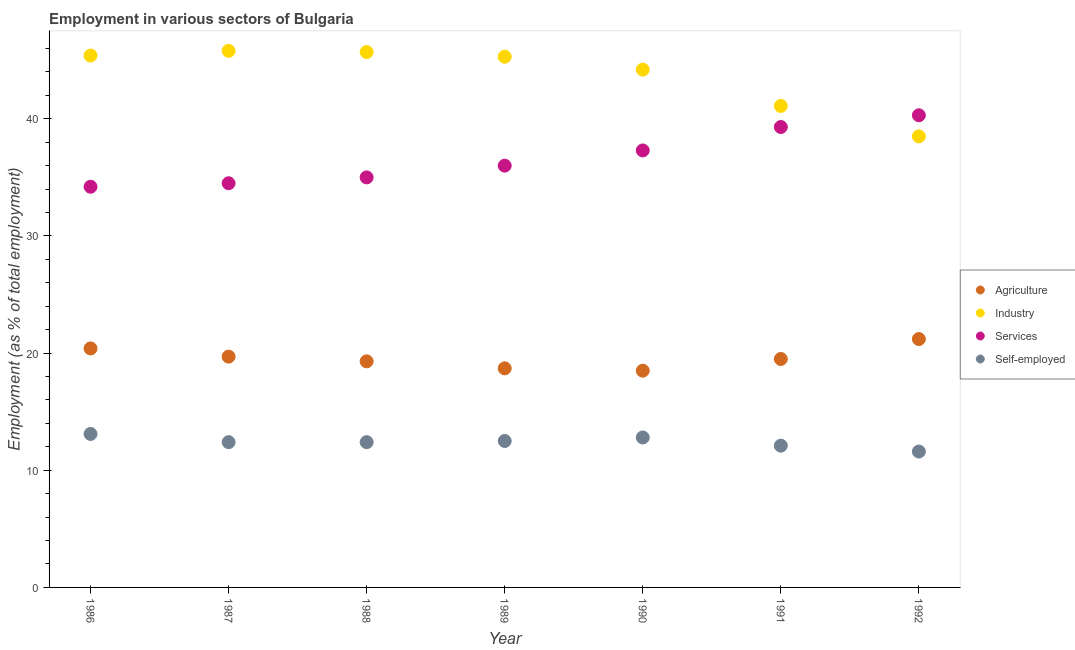How many different coloured dotlines are there?
Your response must be concise. 4. What is the percentage of workers in agriculture in 1988?
Provide a short and direct response. 19.3. Across all years, what is the maximum percentage of workers in services?
Your answer should be very brief. 40.3. Across all years, what is the minimum percentage of workers in industry?
Your answer should be compact. 38.5. In which year was the percentage of workers in industry maximum?
Offer a terse response. 1987. In which year was the percentage of self employed workers minimum?
Make the answer very short. 1992. What is the total percentage of workers in services in the graph?
Ensure brevity in your answer.  256.6. What is the difference between the percentage of workers in agriculture in 1989 and that in 1991?
Provide a short and direct response. -0.8. What is the difference between the percentage of workers in services in 1987 and the percentage of self employed workers in 1988?
Keep it short and to the point. 22.1. What is the average percentage of workers in services per year?
Keep it short and to the point. 36.66. In the year 1988, what is the difference between the percentage of workers in services and percentage of workers in agriculture?
Keep it short and to the point. 15.7. What is the ratio of the percentage of workers in agriculture in 1986 to that in 1988?
Your answer should be compact. 1.06. Is the percentage of workers in services in 1988 less than that in 1992?
Your answer should be very brief. Yes. Is the difference between the percentage of workers in services in 1990 and 1991 greater than the difference between the percentage of self employed workers in 1990 and 1991?
Keep it short and to the point. No. What is the difference between the highest and the second highest percentage of workers in industry?
Provide a succinct answer. 0.1. What is the difference between the highest and the lowest percentage of workers in services?
Ensure brevity in your answer.  6.1. Is it the case that in every year, the sum of the percentage of self employed workers and percentage of workers in services is greater than the sum of percentage of workers in industry and percentage of workers in agriculture?
Provide a succinct answer. Yes. Is it the case that in every year, the sum of the percentage of workers in agriculture and percentage of workers in industry is greater than the percentage of workers in services?
Provide a short and direct response. Yes. Is the percentage of workers in services strictly less than the percentage of workers in industry over the years?
Ensure brevity in your answer.  No. Are the values on the major ticks of Y-axis written in scientific E-notation?
Offer a very short reply. No. Does the graph contain grids?
Keep it short and to the point. No. How are the legend labels stacked?
Your answer should be compact. Vertical. What is the title of the graph?
Make the answer very short. Employment in various sectors of Bulgaria. Does "Salary of employees" appear as one of the legend labels in the graph?
Provide a short and direct response. No. What is the label or title of the Y-axis?
Ensure brevity in your answer.  Employment (as % of total employment). What is the Employment (as % of total employment) of Agriculture in 1986?
Make the answer very short. 20.4. What is the Employment (as % of total employment) in Industry in 1986?
Make the answer very short. 45.4. What is the Employment (as % of total employment) in Services in 1986?
Make the answer very short. 34.2. What is the Employment (as % of total employment) in Self-employed in 1986?
Give a very brief answer. 13.1. What is the Employment (as % of total employment) in Agriculture in 1987?
Ensure brevity in your answer.  19.7. What is the Employment (as % of total employment) of Industry in 1987?
Your response must be concise. 45.8. What is the Employment (as % of total employment) in Services in 1987?
Your answer should be very brief. 34.5. What is the Employment (as % of total employment) of Self-employed in 1987?
Your answer should be very brief. 12.4. What is the Employment (as % of total employment) in Agriculture in 1988?
Provide a succinct answer. 19.3. What is the Employment (as % of total employment) of Industry in 1988?
Your response must be concise. 45.7. What is the Employment (as % of total employment) of Self-employed in 1988?
Your answer should be compact. 12.4. What is the Employment (as % of total employment) of Agriculture in 1989?
Your answer should be very brief. 18.7. What is the Employment (as % of total employment) in Industry in 1989?
Your answer should be compact. 45.3. What is the Employment (as % of total employment) in Services in 1989?
Provide a succinct answer. 36. What is the Employment (as % of total employment) in Self-employed in 1989?
Ensure brevity in your answer.  12.5. What is the Employment (as % of total employment) of Industry in 1990?
Provide a succinct answer. 44.2. What is the Employment (as % of total employment) of Services in 1990?
Your response must be concise. 37.3. What is the Employment (as % of total employment) in Self-employed in 1990?
Give a very brief answer. 12.8. What is the Employment (as % of total employment) of Agriculture in 1991?
Keep it short and to the point. 19.5. What is the Employment (as % of total employment) in Industry in 1991?
Offer a terse response. 41.1. What is the Employment (as % of total employment) of Services in 1991?
Offer a terse response. 39.3. What is the Employment (as % of total employment) in Self-employed in 1991?
Keep it short and to the point. 12.1. What is the Employment (as % of total employment) in Agriculture in 1992?
Keep it short and to the point. 21.2. What is the Employment (as % of total employment) of Industry in 1992?
Your answer should be very brief. 38.5. What is the Employment (as % of total employment) in Services in 1992?
Your answer should be very brief. 40.3. What is the Employment (as % of total employment) of Self-employed in 1992?
Provide a succinct answer. 11.6. Across all years, what is the maximum Employment (as % of total employment) in Agriculture?
Offer a terse response. 21.2. Across all years, what is the maximum Employment (as % of total employment) of Industry?
Make the answer very short. 45.8. Across all years, what is the maximum Employment (as % of total employment) in Services?
Provide a short and direct response. 40.3. Across all years, what is the maximum Employment (as % of total employment) in Self-employed?
Offer a very short reply. 13.1. Across all years, what is the minimum Employment (as % of total employment) of Agriculture?
Offer a terse response. 18.5. Across all years, what is the minimum Employment (as % of total employment) in Industry?
Give a very brief answer. 38.5. Across all years, what is the minimum Employment (as % of total employment) of Services?
Your answer should be compact. 34.2. Across all years, what is the minimum Employment (as % of total employment) in Self-employed?
Provide a succinct answer. 11.6. What is the total Employment (as % of total employment) of Agriculture in the graph?
Ensure brevity in your answer.  137.3. What is the total Employment (as % of total employment) of Industry in the graph?
Provide a short and direct response. 306. What is the total Employment (as % of total employment) in Services in the graph?
Give a very brief answer. 256.6. What is the total Employment (as % of total employment) in Self-employed in the graph?
Give a very brief answer. 86.9. What is the difference between the Employment (as % of total employment) in Agriculture in 1986 and that in 1987?
Your answer should be compact. 0.7. What is the difference between the Employment (as % of total employment) of Services in 1986 and that in 1987?
Keep it short and to the point. -0.3. What is the difference between the Employment (as % of total employment) of Industry in 1986 and that in 1988?
Make the answer very short. -0.3. What is the difference between the Employment (as % of total employment) in Self-employed in 1986 and that in 1988?
Make the answer very short. 0.7. What is the difference between the Employment (as % of total employment) in Agriculture in 1986 and that in 1989?
Ensure brevity in your answer.  1.7. What is the difference between the Employment (as % of total employment) of Services in 1986 and that in 1989?
Keep it short and to the point. -1.8. What is the difference between the Employment (as % of total employment) in Self-employed in 1986 and that in 1989?
Provide a short and direct response. 0.6. What is the difference between the Employment (as % of total employment) of Industry in 1986 and that in 1991?
Your answer should be very brief. 4.3. What is the difference between the Employment (as % of total employment) of Services in 1986 and that in 1991?
Your response must be concise. -5.1. What is the difference between the Employment (as % of total employment) of Industry in 1986 and that in 1992?
Provide a succinct answer. 6.9. What is the difference between the Employment (as % of total employment) of Agriculture in 1987 and that in 1988?
Offer a terse response. 0.4. What is the difference between the Employment (as % of total employment) of Industry in 1987 and that in 1988?
Ensure brevity in your answer.  0.1. What is the difference between the Employment (as % of total employment) in Services in 1987 and that in 1988?
Provide a short and direct response. -0.5. What is the difference between the Employment (as % of total employment) in Agriculture in 1987 and that in 1989?
Your answer should be very brief. 1. What is the difference between the Employment (as % of total employment) of Self-employed in 1987 and that in 1989?
Provide a short and direct response. -0.1. What is the difference between the Employment (as % of total employment) of Industry in 1987 and that in 1990?
Make the answer very short. 1.6. What is the difference between the Employment (as % of total employment) in Services in 1987 and that in 1990?
Make the answer very short. -2.8. What is the difference between the Employment (as % of total employment) of Self-employed in 1987 and that in 1990?
Offer a very short reply. -0.4. What is the difference between the Employment (as % of total employment) in Services in 1987 and that in 1991?
Your answer should be very brief. -4.8. What is the difference between the Employment (as % of total employment) in Self-employed in 1987 and that in 1991?
Your answer should be very brief. 0.3. What is the difference between the Employment (as % of total employment) of Industry in 1987 and that in 1992?
Keep it short and to the point. 7.3. What is the difference between the Employment (as % of total employment) of Services in 1987 and that in 1992?
Provide a short and direct response. -5.8. What is the difference between the Employment (as % of total employment) in Agriculture in 1988 and that in 1989?
Offer a very short reply. 0.6. What is the difference between the Employment (as % of total employment) in Services in 1988 and that in 1989?
Ensure brevity in your answer.  -1. What is the difference between the Employment (as % of total employment) of Self-employed in 1988 and that in 1989?
Provide a short and direct response. -0.1. What is the difference between the Employment (as % of total employment) of Agriculture in 1988 and that in 1990?
Offer a terse response. 0.8. What is the difference between the Employment (as % of total employment) of Industry in 1988 and that in 1990?
Your answer should be compact. 1.5. What is the difference between the Employment (as % of total employment) in Industry in 1988 and that in 1991?
Provide a succinct answer. 4.6. What is the difference between the Employment (as % of total employment) in Services in 1988 and that in 1991?
Keep it short and to the point. -4.3. What is the difference between the Employment (as % of total employment) of Agriculture in 1989 and that in 1990?
Provide a succinct answer. 0.2. What is the difference between the Employment (as % of total employment) in Self-employed in 1989 and that in 1990?
Keep it short and to the point. -0.3. What is the difference between the Employment (as % of total employment) in Agriculture in 1989 and that in 1991?
Give a very brief answer. -0.8. What is the difference between the Employment (as % of total employment) in Industry in 1989 and that in 1991?
Provide a short and direct response. 4.2. What is the difference between the Employment (as % of total employment) of Agriculture in 1989 and that in 1992?
Ensure brevity in your answer.  -2.5. What is the difference between the Employment (as % of total employment) in Industry in 1989 and that in 1992?
Provide a short and direct response. 6.8. What is the difference between the Employment (as % of total employment) in Industry in 1990 and that in 1991?
Provide a succinct answer. 3.1. What is the difference between the Employment (as % of total employment) in Self-employed in 1990 and that in 1991?
Your answer should be very brief. 0.7. What is the difference between the Employment (as % of total employment) in Agriculture in 1990 and that in 1992?
Provide a succinct answer. -2.7. What is the difference between the Employment (as % of total employment) in Services in 1990 and that in 1992?
Your response must be concise. -3. What is the difference between the Employment (as % of total employment) of Self-employed in 1990 and that in 1992?
Make the answer very short. 1.2. What is the difference between the Employment (as % of total employment) in Agriculture in 1991 and that in 1992?
Provide a succinct answer. -1.7. What is the difference between the Employment (as % of total employment) of Industry in 1991 and that in 1992?
Offer a very short reply. 2.6. What is the difference between the Employment (as % of total employment) of Services in 1991 and that in 1992?
Keep it short and to the point. -1. What is the difference between the Employment (as % of total employment) of Self-employed in 1991 and that in 1992?
Give a very brief answer. 0.5. What is the difference between the Employment (as % of total employment) of Agriculture in 1986 and the Employment (as % of total employment) of Industry in 1987?
Ensure brevity in your answer.  -25.4. What is the difference between the Employment (as % of total employment) of Agriculture in 1986 and the Employment (as % of total employment) of Services in 1987?
Offer a very short reply. -14.1. What is the difference between the Employment (as % of total employment) in Industry in 1986 and the Employment (as % of total employment) in Services in 1987?
Provide a succinct answer. 10.9. What is the difference between the Employment (as % of total employment) of Services in 1986 and the Employment (as % of total employment) of Self-employed in 1987?
Provide a succinct answer. 21.8. What is the difference between the Employment (as % of total employment) of Agriculture in 1986 and the Employment (as % of total employment) of Industry in 1988?
Give a very brief answer. -25.3. What is the difference between the Employment (as % of total employment) in Agriculture in 1986 and the Employment (as % of total employment) in Services in 1988?
Keep it short and to the point. -14.6. What is the difference between the Employment (as % of total employment) in Agriculture in 1986 and the Employment (as % of total employment) in Self-employed in 1988?
Your answer should be compact. 8. What is the difference between the Employment (as % of total employment) in Industry in 1986 and the Employment (as % of total employment) in Services in 1988?
Ensure brevity in your answer.  10.4. What is the difference between the Employment (as % of total employment) of Services in 1986 and the Employment (as % of total employment) of Self-employed in 1988?
Offer a very short reply. 21.8. What is the difference between the Employment (as % of total employment) of Agriculture in 1986 and the Employment (as % of total employment) of Industry in 1989?
Your response must be concise. -24.9. What is the difference between the Employment (as % of total employment) of Agriculture in 1986 and the Employment (as % of total employment) of Services in 1989?
Ensure brevity in your answer.  -15.6. What is the difference between the Employment (as % of total employment) in Agriculture in 1986 and the Employment (as % of total employment) in Self-employed in 1989?
Your response must be concise. 7.9. What is the difference between the Employment (as % of total employment) in Industry in 1986 and the Employment (as % of total employment) in Self-employed in 1989?
Provide a short and direct response. 32.9. What is the difference between the Employment (as % of total employment) in Services in 1986 and the Employment (as % of total employment) in Self-employed in 1989?
Offer a terse response. 21.7. What is the difference between the Employment (as % of total employment) in Agriculture in 1986 and the Employment (as % of total employment) in Industry in 1990?
Your response must be concise. -23.8. What is the difference between the Employment (as % of total employment) of Agriculture in 1986 and the Employment (as % of total employment) of Services in 1990?
Ensure brevity in your answer.  -16.9. What is the difference between the Employment (as % of total employment) in Agriculture in 1986 and the Employment (as % of total employment) in Self-employed in 1990?
Provide a succinct answer. 7.6. What is the difference between the Employment (as % of total employment) of Industry in 1986 and the Employment (as % of total employment) of Services in 1990?
Your answer should be very brief. 8.1. What is the difference between the Employment (as % of total employment) in Industry in 1986 and the Employment (as % of total employment) in Self-employed in 1990?
Give a very brief answer. 32.6. What is the difference between the Employment (as % of total employment) of Services in 1986 and the Employment (as % of total employment) of Self-employed in 1990?
Your answer should be compact. 21.4. What is the difference between the Employment (as % of total employment) of Agriculture in 1986 and the Employment (as % of total employment) of Industry in 1991?
Your answer should be very brief. -20.7. What is the difference between the Employment (as % of total employment) of Agriculture in 1986 and the Employment (as % of total employment) of Services in 1991?
Ensure brevity in your answer.  -18.9. What is the difference between the Employment (as % of total employment) in Agriculture in 1986 and the Employment (as % of total employment) in Self-employed in 1991?
Offer a very short reply. 8.3. What is the difference between the Employment (as % of total employment) of Industry in 1986 and the Employment (as % of total employment) of Self-employed in 1991?
Make the answer very short. 33.3. What is the difference between the Employment (as % of total employment) of Services in 1986 and the Employment (as % of total employment) of Self-employed in 1991?
Make the answer very short. 22.1. What is the difference between the Employment (as % of total employment) of Agriculture in 1986 and the Employment (as % of total employment) of Industry in 1992?
Ensure brevity in your answer.  -18.1. What is the difference between the Employment (as % of total employment) of Agriculture in 1986 and the Employment (as % of total employment) of Services in 1992?
Offer a terse response. -19.9. What is the difference between the Employment (as % of total employment) of Industry in 1986 and the Employment (as % of total employment) of Self-employed in 1992?
Provide a short and direct response. 33.8. What is the difference between the Employment (as % of total employment) of Services in 1986 and the Employment (as % of total employment) of Self-employed in 1992?
Your response must be concise. 22.6. What is the difference between the Employment (as % of total employment) of Agriculture in 1987 and the Employment (as % of total employment) of Industry in 1988?
Offer a very short reply. -26. What is the difference between the Employment (as % of total employment) in Agriculture in 1987 and the Employment (as % of total employment) in Services in 1988?
Your answer should be compact. -15.3. What is the difference between the Employment (as % of total employment) in Agriculture in 1987 and the Employment (as % of total employment) in Self-employed in 1988?
Provide a succinct answer. 7.3. What is the difference between the Employment (as % of total employment) in Industry in 1987 and the Employment (as % of total employment) in Services in 1988?
Your answer should be very brief. 10.8. What is the difference between the Employment (as % of total employment) of Industry in 1987 and the Employment (as % of total employment) of Self-employed in 1988?
Your answer should be very brief. 33.4. What is the difference between the Employment (as % of total employment) in Services in 1987 and the Employment (as % of total employment) in Self-employed in 1988?
Give a very brief answer. 22.1. What is the difference between the Employment (as % of total employment) in Agriculture in 1987 and the Employment (as % of total employment) in Industry in 1989?
Provide a succinct answer. -25.6. What is the difference between the Employment (as % of total employment) in Agriculture in 1987 and the Employment (as % of total employment) in Services in 1989?
Your answer should be very brief. -16.3. What is the difference between the Employment (as % of total employment) of Industry in 1987 and the Employment (as % of total employment) of Self-employed in 1989?
Your response must be concise. 33.3. What is the difference between the Employment (as % of total employment) of Agriculture in 1987 and the Employment (as % of total employment) of Industry in 1990?
Offer a very short reply. -24.5. What is the difference between the Employment (as % of total employment) of Agriculture in 1987 and the Employment (as % of total employment) of Services in 1990?
Your answer should be compact. -17.6. What is the difference between the Employment (as % of total employment) of Agriculture in 1987 and the Employment (as % of total employment) of Self-employed in 1990?
Offer a very short reply. 6.9. What is the difference between the Employment (as % of total employment) in Industry in 1987 and the Employment (as % of total employment) in Self-employed in 1990?
Make the answer very short. 33. What is the difference between the Employment (as % of total employment) in Services in 1987 and the Employment (as % of total employment) in Self-employed in 1990?
Offer a very short reply. 21.7. What is the difference between the Employment (as % of total employment) in Agriculture in 1987 and the Employment (as % of total employment) in Industry in 1991?
Your answer should be very brief. -21.4. What is the difference between the Employment (as % of total employment) in Agriculture in 1987 and the Employment (as % of total employment) in Services in 1991?
Keep it short and to the point. -19.6. What is the difference between the Employment (as % of total employment) of Agriculture in 1987 and the Employment (as % of total employment) of Self-employed in 1991?
Provide a succinct answer. 7.6. What is the difference between the Employment (as % of total employment) in Industry in 1987 and the Employment (as % of total employment) in Services in 1991?
Give a very brief answer. 6.5. What is the difference between the Employment (as % of total employment) in Industry in 1987 and the Employment (as % of total employment) in Self-employed in 1991?
Provide a short and direct response. 33.7. What is the difference between the Employment (as % of total employment) of Services in 1987 and the Employment (as % of total employment) of Self-employed in 1991?
Offer a terse response. 22.4. What is the difference between the Employment (as % of total employment) of Agriculture in 1987 and the Employment (as % of total employment) of Industry in 1992?
Your answer should be compact. -18.8. What is the difference between the Employment (as % of total employment) in Agriculture in 1987 and the Employment (as % of total employment) in Services in 1992?
Keep it short and to the point. -20.6. What is the difference between the Employment (as % of total employment) in Agriculture in 1987 and the Employment (as % of total employment) in Self-employed in 1992?
Keep it short and to the point. 8.1. What is the difference between the Employment (as % of total employment) of Industry in 1987 and the Employment (as % of total employment) of Self-employed in 1992?
Your answer should be compact. 34.2. What is the difference between the Employment (as % of total employment) of Services in 1987 and the Employment (as % of total employment) of Self-employed in 1992?
Your response must be concise. 22.9. What is the difference between the Employment (as % of total employment) in Agriculture in 1988 and the Employment (as % of total employment) in Industry in 1989?
Keep it short and to the point. -26. What is the difference between the Employment (as % of total employment) in Agriculture in 1988 and the Employment (as % of total employment) in Services in 1989?
Give a very brief answer. -16.7. What is the difference between the Employment (as % of total employment) in Industry in 1988 and the Employment (as % of total employment) in Self-employed in 1989?
Ensure brevity in your answer.  33.2. What is the difference between the Employment (as % of total employment) of Services in 1988 and the Employment (as % of total employment) of Self-employed in 1989?
Offer a terse response. 22.5. What is the difference between the Employment (as % of total employment) in Agriculture in 1988 and the Employment (as % of total employment) in Industry in 1990?
Offer a terse response. -24.9. What is the difference between the Employment (as % of total employment) of Industry in 1988 and the Employment (as % of total employment) of Services in 1990?
Offer a very short reply. 8.4. What is the difference between the Employment (as % of total employment) in Industry in 1988 and the Employment (as % of total employment) in Self-employed in 1990?
Keep it short and to the point. 32.9. What is the difference between the Employment (as % of total employment) in Services in 1988 and the Employment (as % of total employment) in Self-employed in 1990?
Keep it short and to the point. 22.2. What is the difference between the Employment (as % of total employment) in Agriculture in 1988 and the Employment (as % of total employment) in Industry in 1991?
Offer a terse response. -21.8. What is the difference between the Employment (as % of total employment) of Agriculture in 1988 and the Employment (as % of total employment) of Services in 1991?
Offer a terse response. -20. What is the difference between the Employment (as % of total employment) in Industry in 1988 and the Employment (as % of total employment) in Services in 1991?
Offer a very short reply. 6.4. What is the difference between the Employment (as % of total employment) of Industry in 1988 and the Employment (as % of total employment) of Self-employed in 1991?
Your answer should be very brief. 33.6. What is the difference between the Employment (as % of total employment) in Services in 1988 and the Employment (as % of total employment) in Self-employed in 1991?
Your response must be concise. 22.9. What is the difference between the Employment (as % of total employment) in Agriculture in 1988 and the Employment (as % of total employment) in Industry in 1992?
Your answer should be very brief. -19.2. What is the difference between the Employment (as % of total employment) in Industry in 1988 and the Employment (as % of total employment) in Self-employed in 1992?
Make the answer very short. 34.1. What is the difference between the Employment (as % of total employment) of Services in 1988 and the Employment (as % of total employment) of Self-employed in 1992?
Offer a terse response. 23.4. What is the difference between the Employment (as % of total employment) in Agriculture in 1989 and the Employment (as % of total employment) in Industry in 1990?
Give a very brief answer. -25.5. What is the difference between the Employment (as % of total employment) in Agriculture in 1989 and the Employment (as % of total employment) in Services in 1990?
Your response must be concise. -18.6. What is the difference between the Employment (as % of total employment) of Agriculture in 1989 and the Employment (as % of total employment) of Self-employed in 1990?
Your answer should be compact. 5.9. What is the difference between the Employment (as % of total employment) of Industry in 1989 and the Employment (as % of total employment) of Services in 1990?
Give a very brief answer. 8. What is the difference between the Employment (as % of total employment) of Industry in 1989 and the Employment (as % of total employment) of Self-employed in 1990?
Offer a terse response. 32.5. What is the difference between the Employment (as % of total employment) in Services in 1989 and the Employment (as % of total employment) in Self-employed in 1990?
Offer a very short reply. 23.2. What is the difference between the Employment (as % of total employment) of Agriculture in 1989 and the Employment (as % of total employment) of Industry in 1991?
Offer a very short reply. -22.4. What is the difference between the Employment (as % of total employment) in Agriculture in 1989 and the Employment (as % of total employment) in Services in 1991?
Ensure brevity in your answer.  -20.6. What is the difference between the Employment (as % of total employment) of Industry in 1989 and the Employment (as % of total employment) of Services in 1991?
Ensure brevity in your answer.  6. What is the difference between the Employment (as % of total employment) in Industry in 1989 and the Employment (as % of total employment) in Self-employed in 1991?
Your response must be concise. 33.2. What is the difference between the Employment (as % of total employment) in Services in 1989 and the Employment (as % of total employment) in Self-employed in 1991?
Ensure brevity in your answer.  23.9. What is the difference between the Employment (as % of total employment) in Agriculture in 1989 and the Employment (as % of total employment) in Industry in 1992?
Your response must be concise. -19.8. What is the difference between the Employment (as % of total employment) of Agriculture in 1989 and the Employment (as % of total employment) of Services in 1992?
Ensure brevity in your answer.  -21.6. What is the difference between the Employment (as % of total employment) in Industry in 1989 and the Employment (as % of total employment) in Self-employed in 1992?
Your answer should be compact. 33.7. What is the difference between the Employment (as % of total employment) of Services in 1989 and the Employment (as % of total employment) of Self-employed in 1992?
Your answer should be very brief. 24.4. What is the difference between the Employment (as % of total employment) of Agriculture in 1990 and the Employment (as % of total employment) of Industry in 1991?
Offer a very short reply. -22.6. What is the difference between the Employment (as % of total employment) in Agriculture in 1990 and the Employment (as % of total employment) in Services in 1991?
Provide a succinct answer. -20.8. What is the difference between the Employment (as % of total employment) in Agriculture in 1990 and the Employment (as % of total employment) in Self-employed in 1991?
Make the answer very short. 6.4. What is the difference between the Employment (as % of total employment) in Industry in 1990 and the Employment (as % of total employment) in Services in 1991?
Keep it short and to the point. 4.9. What is the difference between the Employment (as % of total employment) of Industry in 1990 and the Employment (as % of total employment) of Self-employed in 1991?
Provide a short and direct response. 32.1. What is the difference between the Employment (as % of total employment) of Services in 1990 and the Employment (as % of total employment) of Self-employed in 1991?
Ensure brevity in your answer.  25.2. What is the difference between the Employment (as % of total employment) of Agriculture in 1990 and the Employment (as % of total employment) of Services in 1992?
Ensure brevity in your answer.  -21.8. What is the difference between the Employment (as % of total employment) in Agriculture in 1990 and the Employment (as % of total employment) in Self-employed in 1992?
Ensure brevity in your answer.  6.9. What is the difference between the Employment (as % of total employment) in Industry in 1990 and the Employment (as % of total employment) in Self-employed in 1992?
Offer a terse response. 32.6. What is the difference between the Employment (as % of total employment) in Services in 1990 and the Employment (as % of total employment) in Self-employed in 1992?
Offer a terse response. 25.7. What is the difference between the Employment (as % of total employment) of Agriculture in 1991 and the Employment (as % of total employment) of Industry in 1992?
Offer a very short reply. -19. What is the difference between the Employment (as % of total employment) in Agriculture in 1991 and the Employment (as % of total employment) in Services in 1992?
Offer a very short reply. -20.8. What is the difference between the Employment (as % of total employment) in Industry in 1991 and the Employment (as % of total employment) in Self-employed in 1992?
Offer a terse response. 29.5. What is the difference between the Employment (as % of total employment) of Services in 1991 and the Employment (as % of total employment) of Self-employed in 1992?
Offer a terse response. 27.7. What is the average Employment (as % of total employment) of Agriculture per year?
Make the answer very short. 19.61. What is the average Employment (as % of total employment) in Industry per year?
Provide a succinct answer. 43.71. What is the average Employment (as % of total employment) in Services per year?
Give a very brief answer. 36.66. What is the average Employment (as % of total employment) in Self-employed per year?
Make the answer very short. 12.41. In the year 1986, what is the difference between the Employment (as % of total employment) in Agriculture and Employment (as % of total employment) in Industry?
Offer a very short reply. -25. In the year 1986, what is the difference between the Employment (as % of total employment) of Agriculture and Employment (as % of total employment) of Services?
Ensure brevity in your answer.  -13.8. In the year 1986, what is the difference between the Employment (as % of total employment) in Agriculture and Employment (as % of total employment) in Self-employed?
Offer a terse response. 7.3. In the year 1986, what is the difference between the Employment (as % of total employment) in Industry and Employment (as % of total employment) in Services?
Offer a very short reply. 11.2. In the year 1986, what is the difference between the Employment (as % of total employment) of Industry and Employment (as % of total employment) of Self-employed?
Your answer should be compact. 32.3. In the year 1986, what is the difference between the Employment (as % of total employment) of Services and Employment (as % of total employment) of Self-employed?
Offer a very short reply. 21.1. In the year 1987, what is the difference between the Employment (as % of total employment) in Agriculture and Employment (as % of total employment) in Industry?
Your response must be concise. -26.1. In the year 1987, what is the difference between the Employment (as % of total employment) in Agriculture and Employment (as % of total employment) in Services?
Give a very brief answer. -14.8. In the year 1987, what is the difference between the Employment (as % of total employment) of Industry and Employment (as % of total employment) of Self-employed?
Ensure brevity in your answer.  33.4. In the year 1987, what is the difference between the Employment (as % of total employment) in Services and Employment (as % of total employment) in Self-employed?
Provide a short and direct response. 22.1. In the year 1988, what is the difference between the Employment (as % of total employment) in Agriculture and Employment (as % of total employment) in Industry?
Offer a very short reply. -26.4. In the year 1988, what is the difference between the Employment (as % of total employment) in Agriculture and Employment (as % of total employment) in Services?
Your response must be concise. -15.7. In the year 1988, what is the difference between the Employment (as % of total employment) in Industry and Employment (as % of total employment) in Self-employed?
Keep it short and to the point. 33.3. In the year 1988, what is the difference between the Employment (as % of total employment) of Services and Employment (as % of total employment) of Self-employed?
Your response must be concise. 22.6. In the year 1989, what is the difference between the Employment (as % of total employment) in Agriculture and Employment (as % of total employment) in Industry?
Your answer should be compact. -26.6. In the year 1989, what is the difference between the Employment (as % of total employment) in Agriculture and Employment (as % of total employment) in Services?
Your answer should be very brief. -17.3. In the year 1989, what is the difference between the Employment (as % of total employment) in Agriculture and Employment (as % of total employment) in Self-employed?
Your response must be concise. 6.2. In the year 1989, what is the difference between the Employment (as % of total employment) in Industry and Employment (as % of total employment) in Services?
Give a very brief answer. 9.3. In the year 1989, what is the difference between the Employment (as % of total employment) in Industry and Employment (as % of total employment) in Self-employed?
Your answer should be compact. 32.8. In the year 1990, what is the difference between the Employment (as % of total employment) in Agriculture and Employment (as % of total employment) in Industry?
Keep it short and to the point. -25.7. In the year 1990, what is the difference between the Employment (as % of total employment) of Agriculture and Employment (as % of total employment) of Services?
Offer a terse response. -18.8. In the year 1990, what is the difference between the Employment (as % of total employment) in Agriculture and Employment (as % of total employment) in Self-employed?
Your response must be concise. 5.7. In the year 1990, what is the difference between the Employment (as % of total employment) of Industry and Employment (as % of total employment) of Self-employed?
Your answer should be compact. 31.4. In the year 1990, what is the difference between the Employment (as % of total employment) in Services and Employment (as % of total employment) in Self-employed?
Your answer should be very brief. 24.5. In the year 1991, what is the difference between the Employment (as % of total employment) of Agriculture and Employment (as % of total employment) of Industry?
Provide a short and direct response. -21.6. In the year 1991, what is the difference between the Employment (as % of total employment) in Agriculture and Employment (as % of total employment) in Services?
Your response must be concise. -19.8. In the year 1991, what is the difference between the Employment (as % of total employment) of Services and Employment (as % of total employment) of Self-employed?
Offer a terse response. 27.2. In the year 1992, what is the difference between the Employment (as % of total employment) of Agriculture and Employment (as % of total employment) of Industry?
Your answer should be very brief. -17.3. In the year 1992, what is the difference between the Employment (as % of total employment) in Agriculture and Employment (as % of total employment) in Services?
Keep it short and to the point. -19.1. In the year 1992, what is the difference between the Employment (as % of total employment) in Agriculture and Employment (as % of total employment) in Self-employed?
Your response must be concise. 9.6. In the year 1992, what is the difference between the Employment (as % of total employment) of Industry and Employment (as % of total employment) of Services?
Provide a short and direct response. -1.8. In the year 1992, what is the difference between the Employment (as % of total employment) in Industry and Employment (as % of total employment) in Self-employed?
Your answer should be very brief. 26.9. In the year 1992, what is the difference between the Employment (as % of total employment) of Services and Employment (as % of total employment) of Self-employed?
Make the answer very short. 28.7. What is the ratio of the Employment (as % of total employment) of Agriculture in 1986 to that in 1987?
Your response must be concise. 1.04. What is the ratio of the Employment (as % of total employment) in Industry in 1986 to that in 1987?
Make the answer very short. 0.99. What is the ratio of the Employment (as % of total employment) of Services in 1986 to that in 1987?
Your response must be concise. 0.99. What is the ratio of the Employment (as % of total employment) of Self-employed in 1986 to that in 1987?
Offer a terse response. 1.06. What is the ratio of the Employment (as % of total employment) of Agriculture in 1986 to that in 1988?
Your response must be concise. 1.06. What is the ratio of the Employment (as % of total employment) in Industry in 1986 to that in 1988?
Provide a succinct answer. 0.99. What is the ratio of the Employment (as % of total employment) in Services in 1986 to that in 1988?
Your answer should be very brief. 0.98. What is the ratio of the Employment (as % of total employment) of Self-employed in 1986 to that in 1988?
Offer a terse response. 1.06. What is the ratio of the Employment (as % of total employment) in Agriculture in 1986 to that in 1989?
Your answer should be compact. 1.09. What is the ratio of the Employment (as % of total employment) of Self-employed in 1986 to that in 1989?
Offer a very short reply. 1.05. What is the ratio of the Employment (as % of total employment) of Agriculture in 1986 to that in 1990?
Your response must be concise. 1.1. What is the ratio of the Employment (as % of total employment) in Industry in 1986 to that in 1990?
Your response must be concise. 1.03. What is the ratio of the Employment (as % of total employment) in Services in 1986 to that in 1990?
Your response must be concise. 0.92. What is the ratio of the Employment (as % of total employment) in Self-employed in 1986 to that in 1990?
Give a very brief answer. 1.02. What is the ratio of the Employment (as % of total employment) of Agriculture in 1986 to that in 1991?
Your answer should be very brief. 1.05. What is the ratio of the Employment (as % of total employment) of Industry in 1986 to that in 1991?
Offer a terse response. 1.1. What is the ratio of the Employment (as % of total employment) in Services in 1986 to that in 1991?
Your answer should be very brief. 0.87. What is the ratio of the Employment (as % of total employment) in Self-employed in 1986 to that in 1991?
Ensure brevity in your answer.  1.08. What is the ratio of the Employment (as % of total employment) in Agriculture in 1986 to that in 1992?
Keep it short and to the point. 0.96. What is the ratio of the Employment (as % of total employment) in Industry in 1986 to that in 1992?
Provide a succinct answer. 1.18. What is the ratio of the Employment (as % of total employment) of Services in 1986 to that in 1992?
Make the answer very short. 0.85. What is the ratio of the Employment (as % of total employment) in Self-employed in 1986 to that in 1992?
Your answer should be very brief. 1.13. What is the ratio of the Employment (as % of total employment) of Agriculture in 1987 to that in 1988?
Provide a succinct answer. 1.02. What is the ratio of the Employment (as % of total employment) in Services in 1987 to that in 1988?
Provide a succinct answer. 0.99. What is the ratio of the Employment (as % of total employment) of Agriculture in 1987 to that in 1989?
Your response must be concise. 1.05. What is the ratio of the Employment (as % of total employment) in Services in 1987 to that in 1989?
Your response must be concise. 0.96. What is the ratio of the Employment (as % of total employment) of Self-employed in 1987 to that in 1989?
Your response must be concise. 0.99. What is the ratio of the Employment (as % of total employment) in Agriculture in 1987 to that in 1990?
Give a very brief answer. 1.06. What is the ratio of the Employment (as % of total employment) of Industry in 1987 to that in 1990?
Offer a terse response. 1.04. What is the ratio of the Employment (as % of total employment) of Services in 1987 to that in 1990?
Your answer should be compact. 0.92. What is the ratio of the Employment (as % of total employment) of Self-employed in 1987 to that in 1990?
Your response must be concise. 0.97. What is the ratio of the Employment (as % of total employment) in Agriculture in 1987 to that in 1991?
Ensure brevity in your answer.  1.01. What is the ratio of the Employment (as % of total employment) of Industry in 1987 to that in 1991?
Your answer should be very brief. 1.11. What is the ratio of the Employment (as % of total employment) in Services in 1987 to that in 1991?
Offer a terse response. 0.88. What is the ratio of the Employment (as % of total employment) in Self-employed in 1987 to that in 1991?
Your answer should be compact. 1.02. What is the ratio of the Employment (as % of total employment) in Agriculture in 1987 to that in 1992?
Your answer should be compact. 0.93. What is the ratio of the Employment (as % of total employment) of Industry in 1987 to that in 1992?
Offer a very short reply. 1.19. What is the ratio of the Employment (as % of total employment) in Services in 1987 to that in 1992?
Provide a succinct answer. 0.86. What is the ratio of the Employment (as % of total employment) of Self-employed in 1987 to that in 1992?
Your response must be concise. 1.07. What is the ratio of the Employment (as % of total employment) in Agriculture in 1988 to that in 1989?
Keep it short and to the point. 1.03. What is the ratio of the Employment (as % of total employment) in Industry in 1988 to that in 1989?
Make the answer very short. 1.01. What is the ratio of the Employment (as % of total employment) of Services in 1988 to that in 1989?
Your response must be concise. 0.97. What is the ratio of the Employment (as % of total employment) of Self-employed in 1988 to that in 1989?
Provide a succinct answer. 0.99. What is the ratio of the Employment (as % of total employment) in Agriculture in 1988 to that in 1990?
Offer a very short reply. 1.04. What is the ratio of the Employment (as % of total employment) of Industry in 1988 to that in 1990?
Keep it short and to the point. 1.03. What is the ratio of the Employment (as % of total employment) of Services in 1988 to that in 1990?
Your answer should be very brief. 0.94. What is the ratio of the Employment (as % of total employment) of Self-employed in 1988 to that in 1990?
Your response must be concise. 0.97. What is the ratio of the Employment (as % of total employment) in Agriculture in 1988 to that in 1991?
Ensure brevity in your answer.  0.99. What is the ratio of the Employment (as % of total employment) in Industry in 1988 to that in 1991?
Give a very brief answer. 1.11. What is the ratio of the Employment (as % of total employment) in Services in 1988 to that in 1991?
Give a very brief answer. 0.89. What is the ratio of the Employment (as % of total employment) of Self-employed in 1988 to that in 1991?
Give a very brief answer. 1.02. What is the ratio of the Employment (as % of total employment) in Agriculture in 1988 to that in 1992?
Ensure brevity in your answer.  0.91. What is the ratio of the Employment (as % of total employment) of Industry in 1988 to that in 1992?
Provide a succinct answer. 1.19. What is the ratio of the Employment (as % of total employment) of Services in 1988 to that in 1992?
Make the answer very short. 0.87. What is the ratio of the Employment (as % of total employment) of Self-employed in 1988 to that in 1992?
Give a very brief answer. 1.07. What is the ratio of the Employment (as % of total employment) of Agriculture in 1989 to that in 1990?
Provide a succinct answer. 1.01. What is the ratio of the Employment (as % of total employment) of Industry in 1989 to that in 1990?
Offer a terse response. 1.02. What is the ratio of the Employment (as % of total employment) of Services in 1989 to that in 1990?
Ensure brevity in your answer.  0.97. What is the ratio of the Employment (as % of total employment) in Self-employed in 1989 to that in 1990?
Keep it short and to the point. 0.98. What is the ratio of the Employment (as % of total employment) in Industry in 1989 to that in 1991?
Make the answer very short. 1.1. What is the ratio of the Employment (as % of total employment) of Services in 1989 to that in 1991?
Ensure brevity in your answer.  0.92. What is the ratio of the Employment (as % of total employment) in Self-employed in 1989 to that in 1991?
Your answer should be compact. 1.03. What is the ratio of the Employment (as % of total employment) in Agriculture in 1989 to that in 1992?
Your response must be concise. 0.88. What is the ratio of the Employment (as % of total employment) of Industry in 1989 to that in 1992?
Your answer should be compact. 1.18. What is the ratio of the Employment (as % of total employment) of Services in 1989 to that in 1992?
Offer a terse response. 0.89. What is the ratio of the Employment (as % of total employment) in Self-employed in 1989 to that in 1992?
Keep it short and to the point. 1.08. What is the ratio of the Employment (as % of total employment) in Agriculture in 1990 to that in 1991?
Your response must be concise. 0.95. What is the ratio of the Employment (as % of total employment) of Industry in 1990 to that in 1991?
Provide a short and direct response. 1.08. What is the ratio of the Employment (as % of total employment) in Services in 1990 to that in 1991?
Your response must be concise. 0.95. What is the ratio of the Employment (as % of total employment) in Self-employed in 1990 to that in 1991?
Provide a succinct answer. 1.06. What is the ratio of the Employment (as % of total employment) in Agriculture in 1990 to that in 1992?
Your answer should be compact. 0.87. What is the ratio of the Employment (as % of total employment) of Industry in 1990 to that in 1992?
Your response must be concise. 1.15. What is the ratio of the Employment (as % of total employment) of Services in 1990 to that in 1992?
Keep it short and to the point. 0.93. What is the ratio of the Employment (as % of total employment) of Self-employed in 1990 to that in 1992?
Keep it short and to the point. 1.1. What is the ratio of the Employment (as % of total employment) of Agriculture in 1991 to that in 1992?
Make the answer very short. 0.92. What is the ratio of the Employment (as % of total employment) of Industry in 1991 to that in 1992?
Ensure brevity in your answer.  1.07. What is the ratio of the Employment (as % of total employment) of Services in 1991 to that in 1992?
Your answer should be compact. 0.98. What is the ratio of the Employment (as % of total employment) in Self-employed in 1991 to that in 1992?
Make the answer very short. 1.04. What is the difference between the highest and the second highest Employment (as % of total employment) in Agriculture?
Your answer should be compact. 0.8. What is the difference between the highest and the second highest Employment (as % of total employment) in Industry?
Offer a very short reply. 0.1. What is the difference between the highest and the lowest Employment (as % of total employment) of Agriculture?
Offer a terse response. 2.7. What is the difference between the highest and the lowest Employment (as % of total employment) in Services?
Provide a succinct answer. 6.1. 